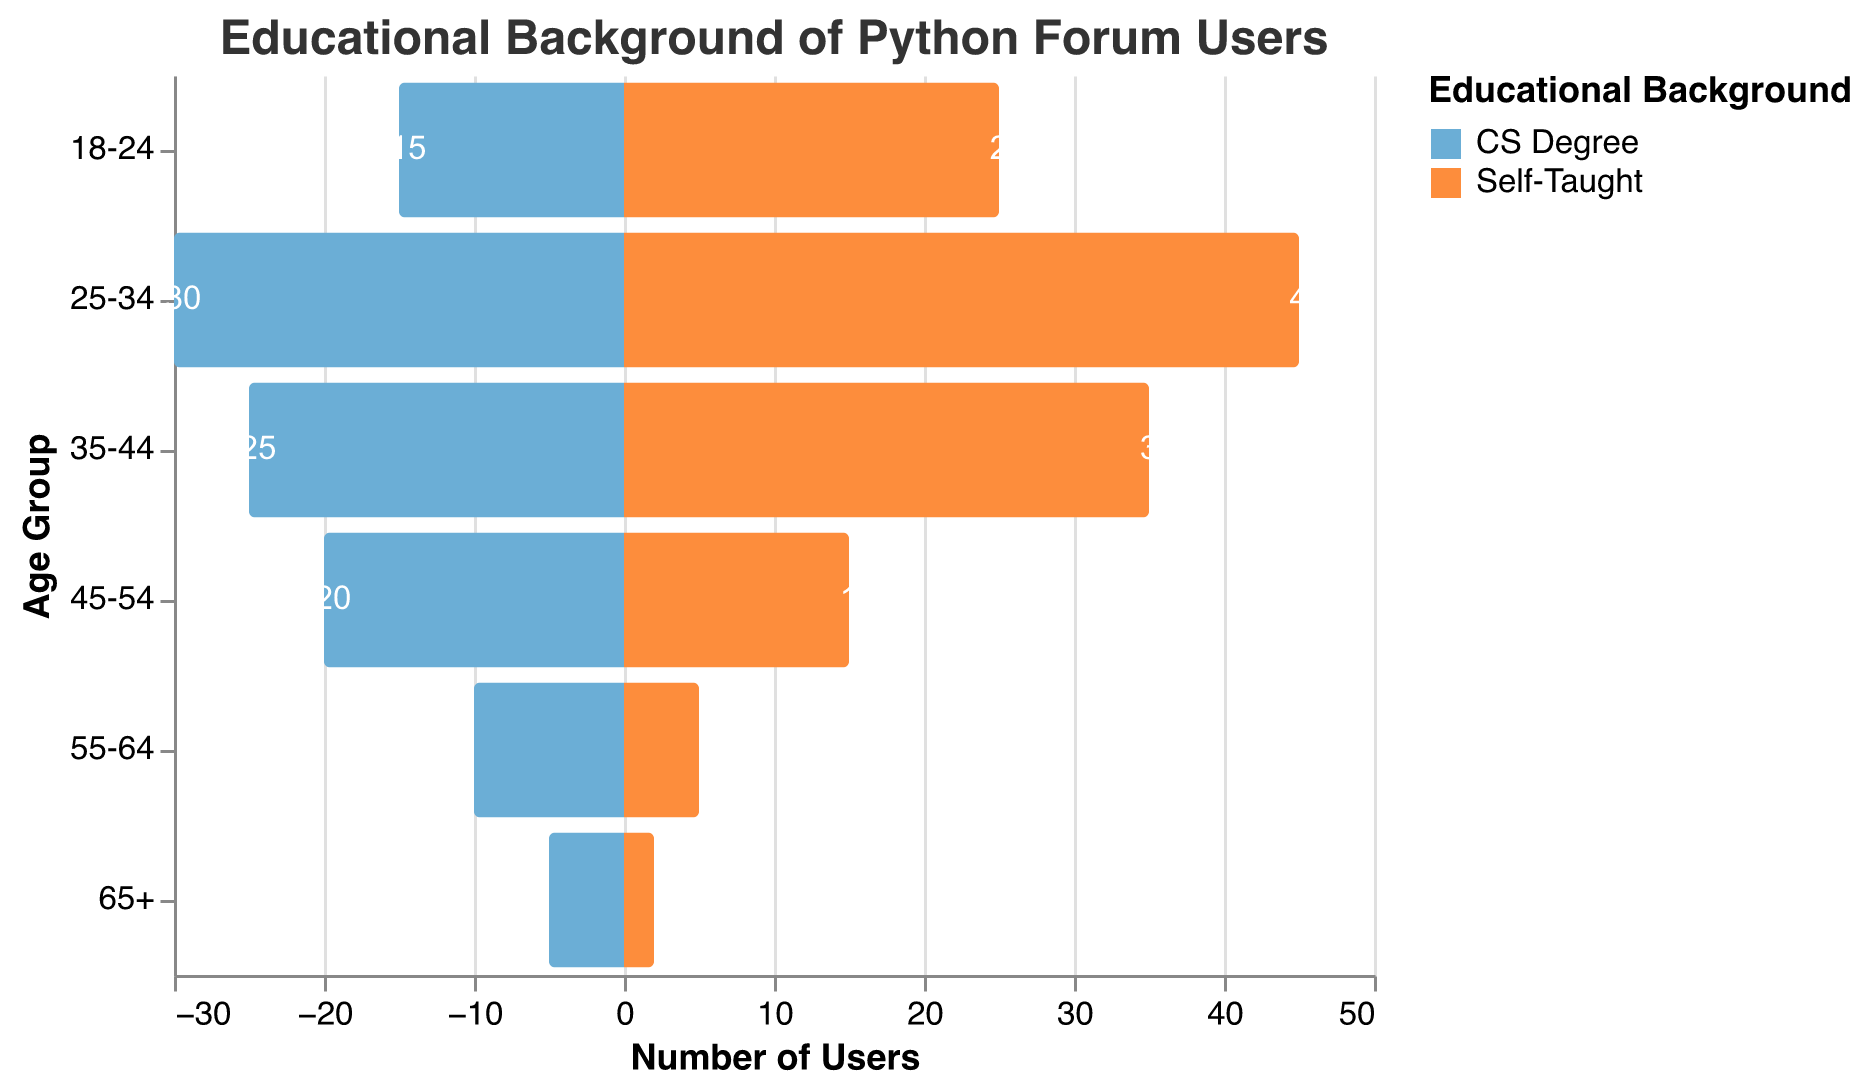What title is displayed at the top of the chart? The title is located at the top of the chart and reads "Educational Background of Python Forum Users".
Answer: Educational Background of Python Forum Users Which age group has the highest number of self-taught Python forum users? By examining the bar lengths for the "Self-Taught" category, the age group 25-34 has the longest bar, indicating the highest count.
Answer: 25-34 In the age group 45-54, which category has more users? Comparing the bar lengths for the age group 45-54, the "CS Degree" bar is longer than the "Self-Taught" bar.
Answer: CS Degree How many total users in the age group 18-24 have either a CS degree or are self-taught? Adding the values for CS Degree and Self-Taught for the age group 18-24 yields 15 + 25.
Answer: 40 Which age group has the smallest difference in user numbers between CS Degree and Self-Taught categories? Calculate the absolute differences: 18-24 (10), 25-34 (15), 35-44 (10), 45-54 (5), 55-64 (5), 65+ (3). The smallest difference is 65+.
Answer: 65+ For the 25-34 age group, by how many users does the number of self-taught developers exceed those with a CS degree? Subtract the number of CS Degree users from Self-Taught users in the 25-34 age group: 45 - 30.
Answer: 15 In which two age groups do self-taught users outnumber those with CS degrees? Compare the bar lengths for each age group: 18-24 and 25-34 show longer bars for Self-Taught than for CS Degree.
Answer: 18-24, 25-34 What proportion of users aged 55-64 are self-taught among all users in that age group? Add the values for CS Degree and Self-Taught in the 55-64 group: 10 + 5 = 15. Then, calculate the proportion of Self-Taught: 5/15 * 100.
Answer: 33.3% If you combine the total number of CS Degree and Self-Taught users aged 25-34, what percentage of the total population across all age groups does this account for? First, find the total population in the chart (sum of all values): (15+25) + (30+45) + (25+35) + (20+15) + (10+5) + (5+2) = 297; sum the relevant age group: 30+45 = 75. Then, calculate the percentage: (75 / 297) * 100.
Answer: 25.3% 